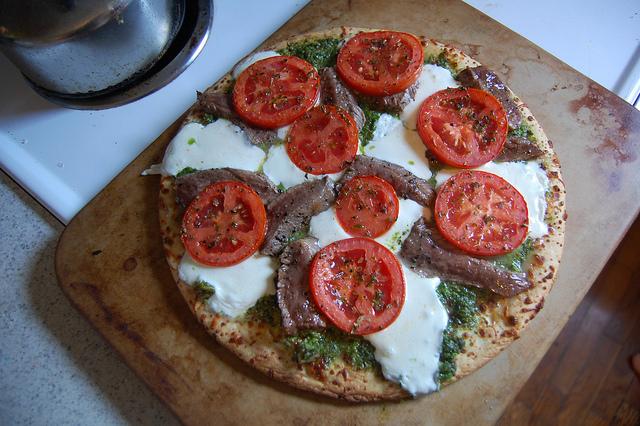Does this pizza have tomato sauce?
Quick response, please. No. What paste is used to make this pizza?
Quick response, please. Tomato. How many tomato slices are there?
Quick response, please. 8. Is this a taco?
Answer briefly. No. What are the purple things on the pizza?
Short answer required. Fish. How many slices of tomatoes do you see?
Be succinct. 8. 